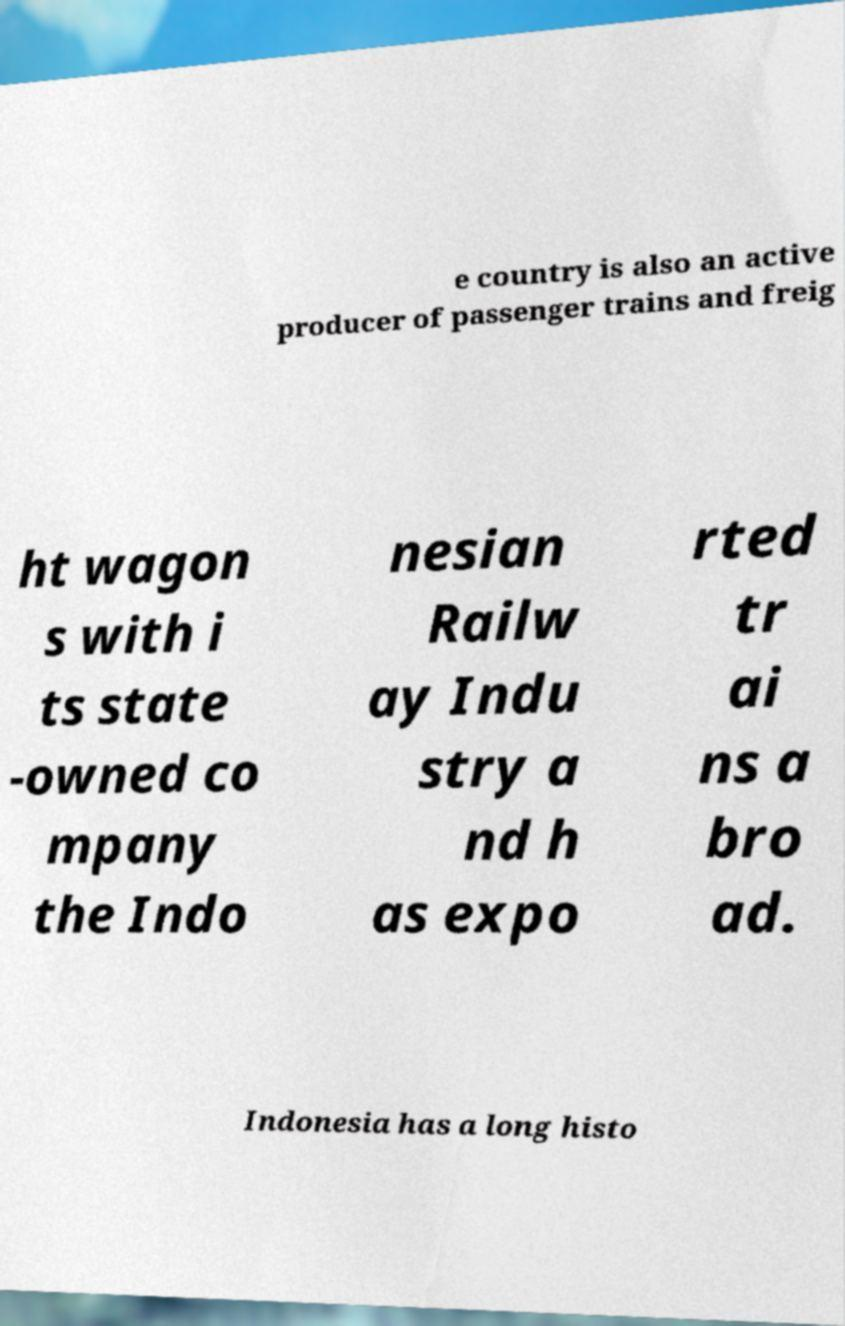There's text embedded in this image that I need extracted. Can you transcribe it verbatim? e country is also an active producer of passenger trains and freig ht wagon s with i ts state -owned co mpany the Indo nesian Railw ay Indu stry a nd h as expo rted tr ai ns a bro ad. Indonesia has a long histo 